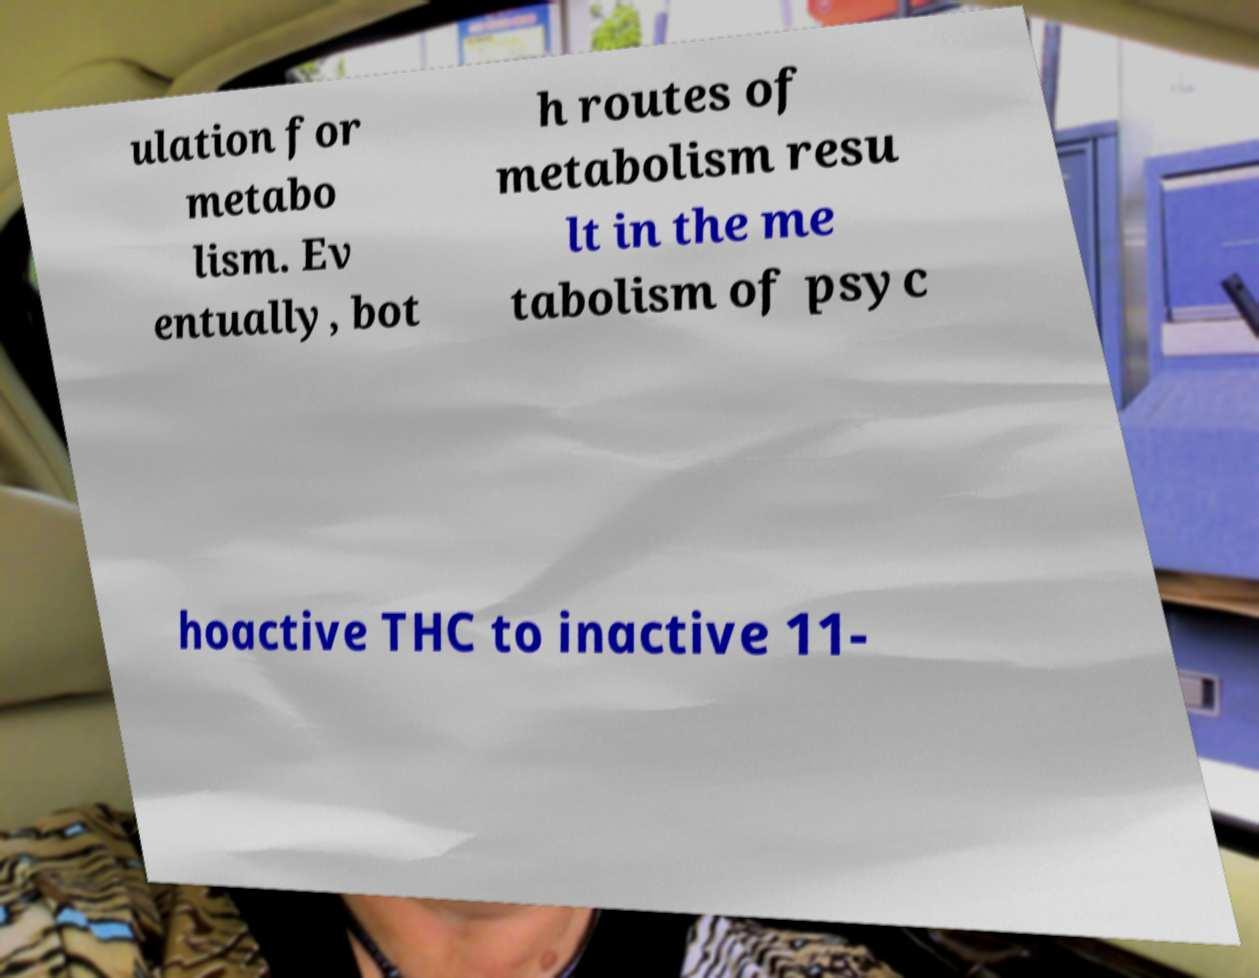What messages or text are displayed in this image? I need them in a readable, typed format. ulation for metabo lism. Ev entually, bot h routes of metabolism resu lt in the me tabolism of psyc hoactive THC to inactive 11- 